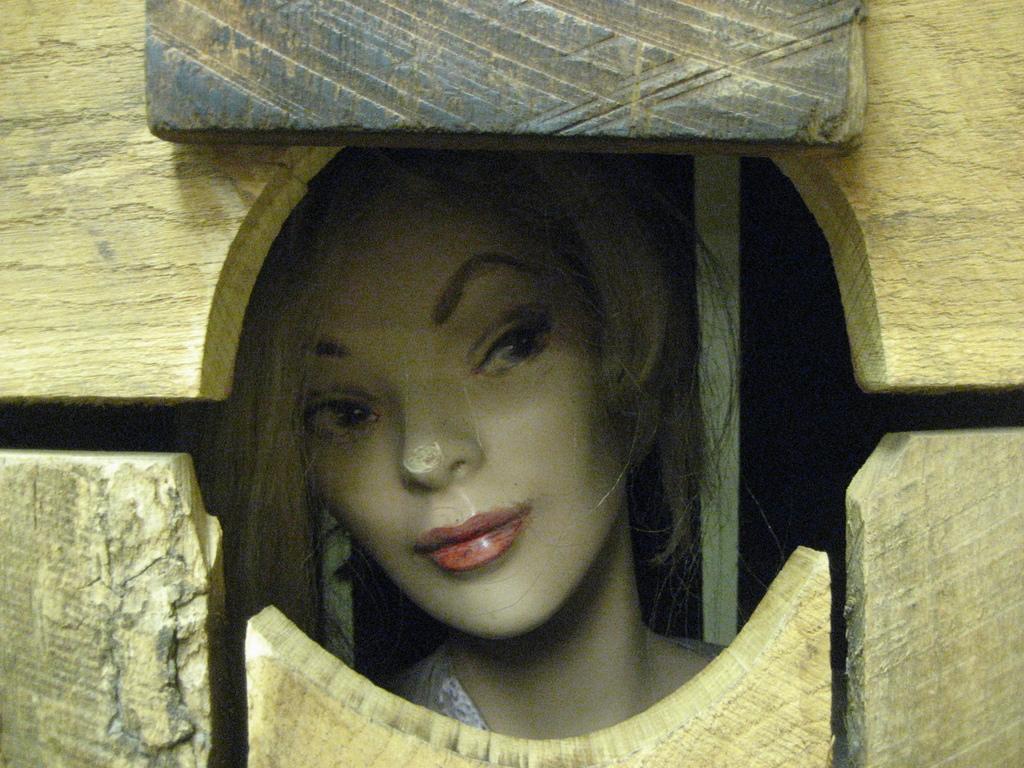In one or two sentences, can you explain what this image depicts? In the image we can see a female toy and this is a wooden cage. 